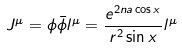<formula> <loc_0><loc_0><loc_500><loc_500>J ^ { \mu } = { \phi } \bar { \phi } l ^ { \mu } = \frac { e ^ { 2 n a \cos x } } { r ^ { 2 } \sin x } l ^ { \mu }</formula> 